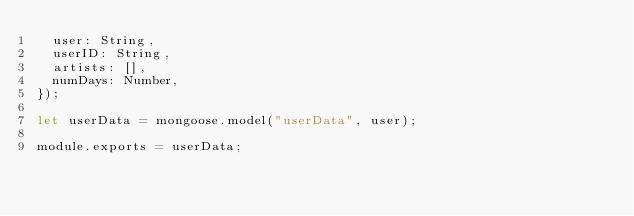Convert code to text. <code><loc_0><loc_0><loc_500><loc_500><_JavaScript_>  user: String,
  userID: String,
  artists: [],
  numDays: Number,
});

let userData = mongoose.model("userData", user);

module.exports = userData;
</code> 